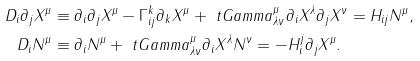Convert formula to latex. <formula><loc_0><loc_0><loc_500><loc_500>D _ { i } \partial _ { j } X ^ { \mu } & \equiv \partial _ { i } \partial _ { j } X ^ { \mu } - \Gamma ^ { k } _ { i j } \partial _ { k } X ^ { \mu } + \ t G a m m a ^ { \mu } _ { \lambda \nu } \partial _ { i } X ^ { \lambda } \partial _ { j } X ^ { \nu } = H _ { i j } N ^ { \mu } , \\ D _ { i } N ^ { \mu } & \equiv \partial _ { i } N ^ { \mu } + \ t G a m m a ^ { \mu } _ { \lambda \nu } \partial _ { i } X ^ { \lambda } N ^ { \nu } = - H _ { i } ^ { j } \partial _ { j } X ^ { \mu } .</formula> 